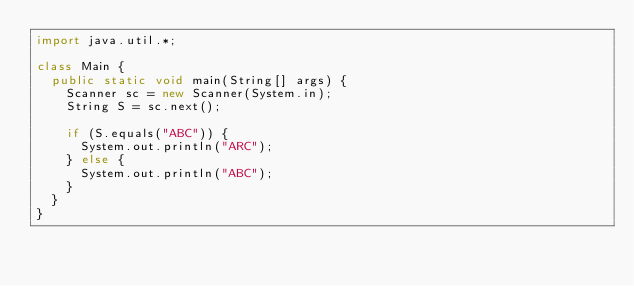<code> <loc_0><loc_0><loc_500><loc_500><_Java_>import java.util.*;

class Main {
  public static void main(String[] args) {
    Scanner sc = new Scanner(System.in);
    String S = sc.next();

    if (S.equals("ABC")) {
      System.out.println("ARC");
    } else {
      System.out.println("ABC");
    }
  }
}</code> 